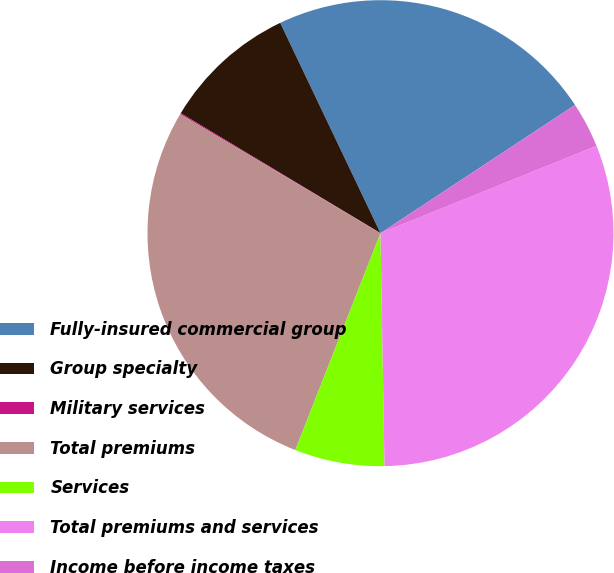Convert chart. <chart><loc_0><loc_0><loc_500><loc_500><pie_chart><fcel>Fully-insured commercial group<fcel>Group specialty<fcel>Military services<fcel>Total premiums<fcel>Services<fcel>Total premiums and services<fcel>Income before income taxes<nl><fcel>22.81%<fcel>9.31%<fcel>0.08%<fcel>27.58%<fcel>6.23%<fcel>30.84%<fcel>3.16%<nl></chart> 